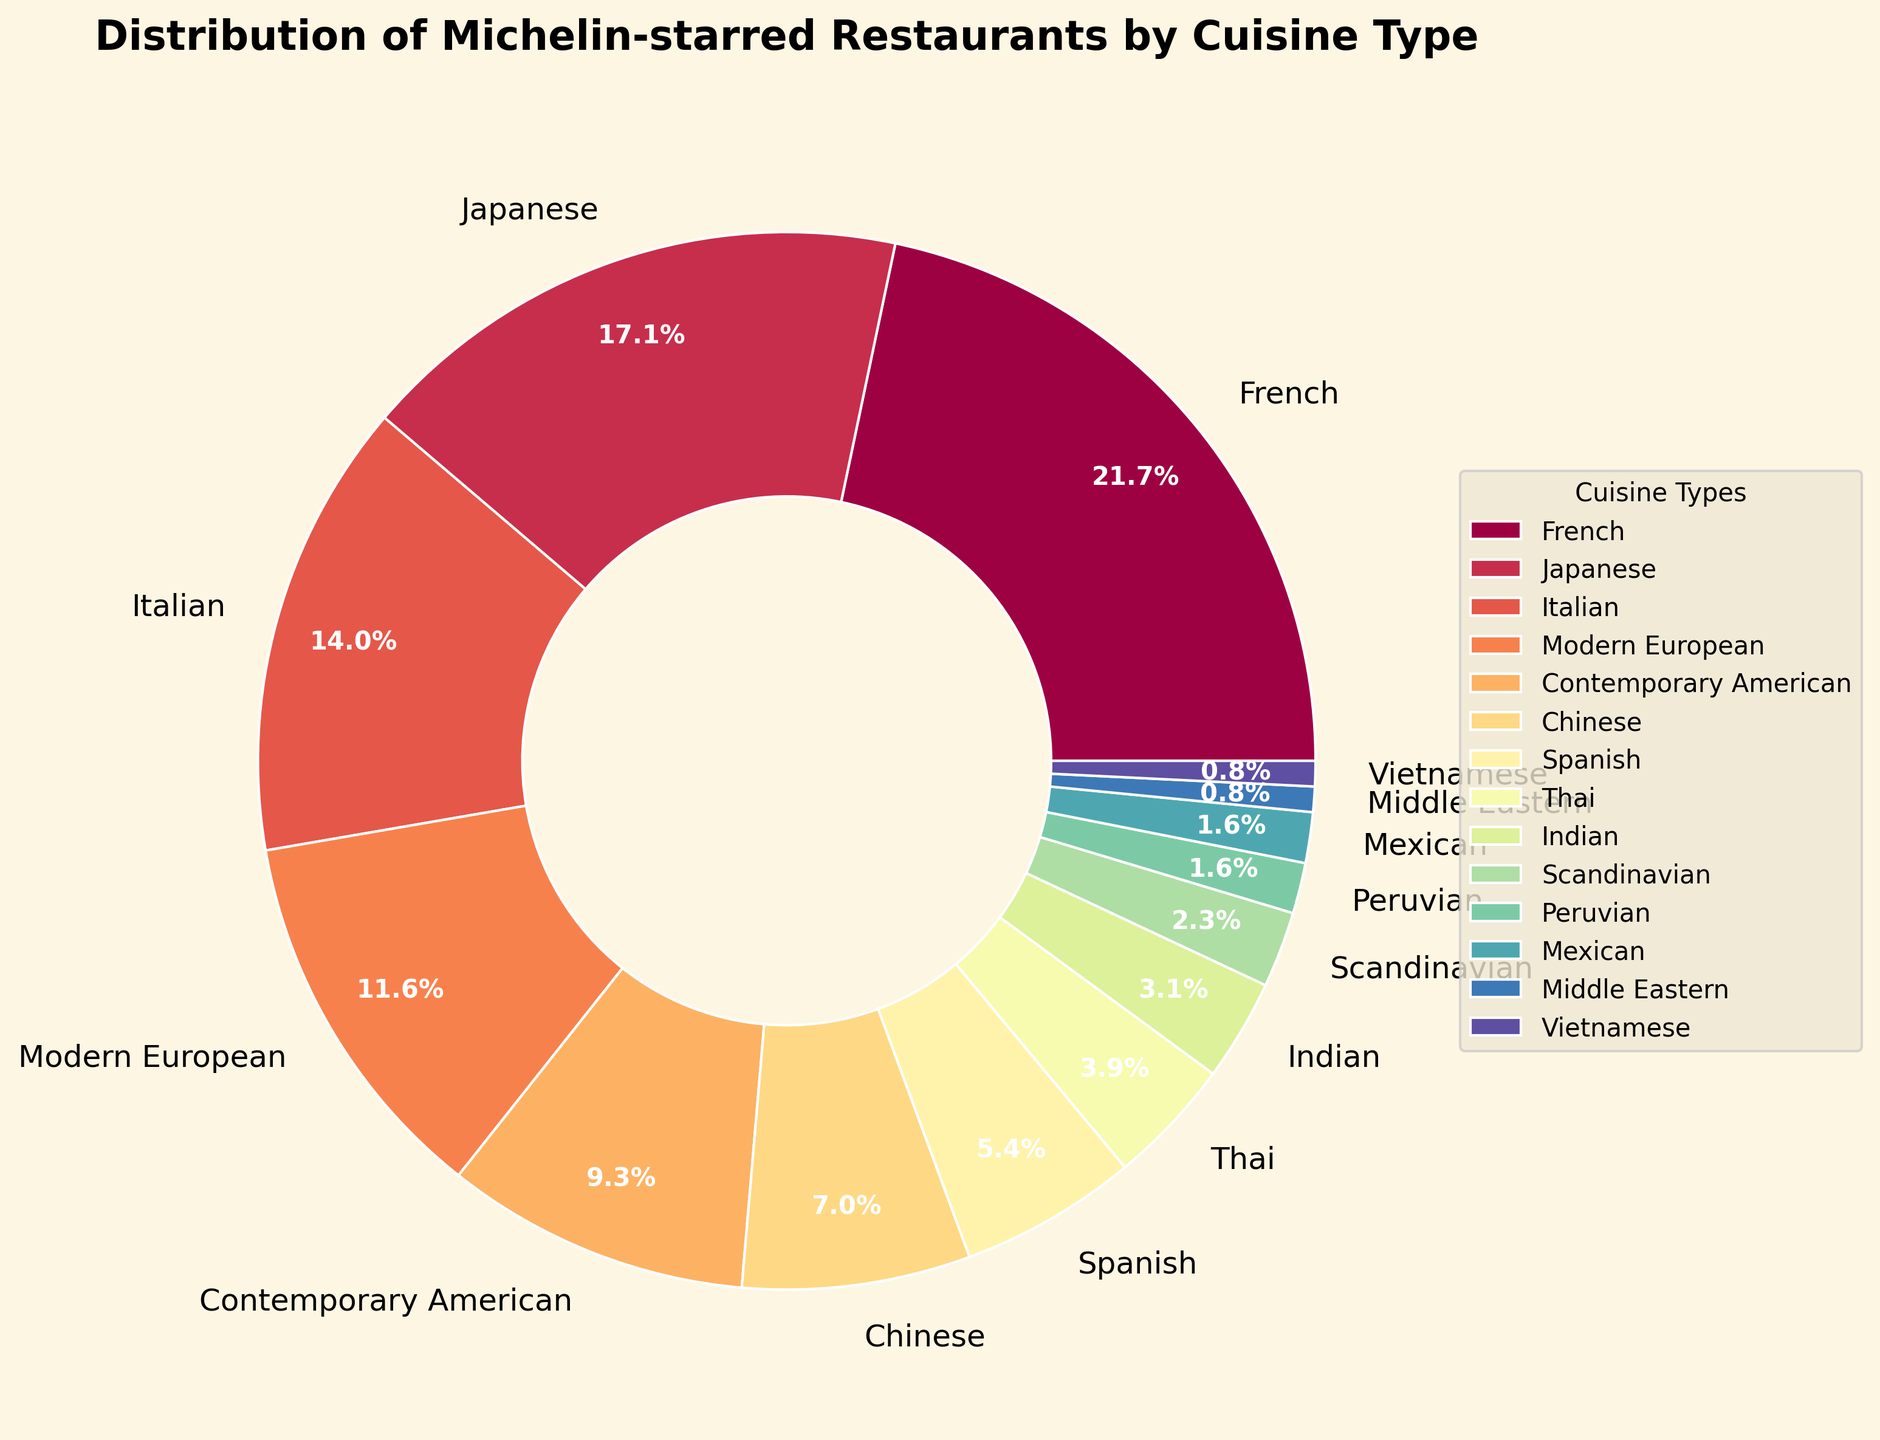Which cuisine type has the highest number of Michelin-starred restaurants? The pie chart shows that the segment with the label "French" is the largest.
Answer: French Between Italian and Japanese cuisines, which has more Michelin-starred restaurants? By comparing the sizes of the segments labeled "Italian" and "Japanese", the Japanese section is larger.
Answer: Japanese How many more Michelin-starred restaurants are there for French cuisine compared to Indian cuisine? The French segment has 28 restaurants, and the Indian segment has 4. Subtracting these gives 28 - 4.
Answer: 24 If you combine the number of Michelin-starred restaurants for Mexican, Peruvian, Middle Eastern, and Vietnamese cuisines, what percentage of the total do they represent? Mexican and Peruvian each have 2, Middle Eastern and Vietnamese each have 1. Total = 2+2+1+1 = 6. The total in the chart is 130. Percentage = (6/130) * 100.
Answer: 4.6% Which cuisine has nearly twice the number of Michelin-starred restaurants as Spanish cuisine? Spanish cuisine has 7 restaurants. Modern European has 15, which is more than twice 7.
Answer: Modern European Which two cuisines have the smallest share of Michelin-starred restaurants, and are they equal in number? Both Middle Eastern and Vietnamese cuisines have only one Michelin-starred restaurant each.
Answer: Middle Eastern and Vietnamese, yes Arrange the following cuisines in descending order of Michelin-starred restaurants: Modern European, Contemporary American, Scandinavian. Modern European has 15, Contemporary American has 12, and Scandinavian has 3. So the order is Modern European > Contemporary American > Scandinavian.
Answer: Modern European, Contemporary American, Scandinavian What percentage of Michelin-starred restaurants are represented by the top two cuisine types combined? French has 28 and Japanese has 22. Total = 28+22 = 50. The total in the chart is 130. Percentage = (50/130) * 100.
Answer: 38.5% Which segment in the pie chart is colored closest to red? The pie chart uses the Spectral colormap where hues change gradually. The Italian segment visually appears in the range closest to red.
Answer: Italian 